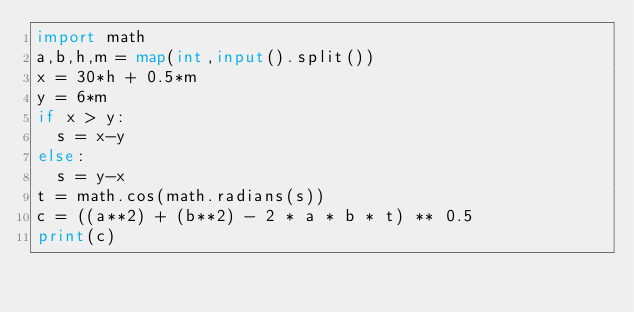<code> <loc_0><loc_0><loc_500><loc_500><_Python_>import math
a,b,h,m = map(int,input().split())
x = 30*h + 0.5*m
y = 6*m
if x > y:
  s = x-y
else:
  s = y-x
t = math.cos(math.radians(s))
c = ((a**2) + (b**2) - 2 * a * b * t) ** 0.5
print(c)</code> 